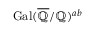Convert formula to latex. <formula><loc_0><loc_0><loc_500><loc_500>{ G a l } ( { \overline { { \mathbb { Q } } } } / \mathbb { Q } ) ^ { a b }</formula> 